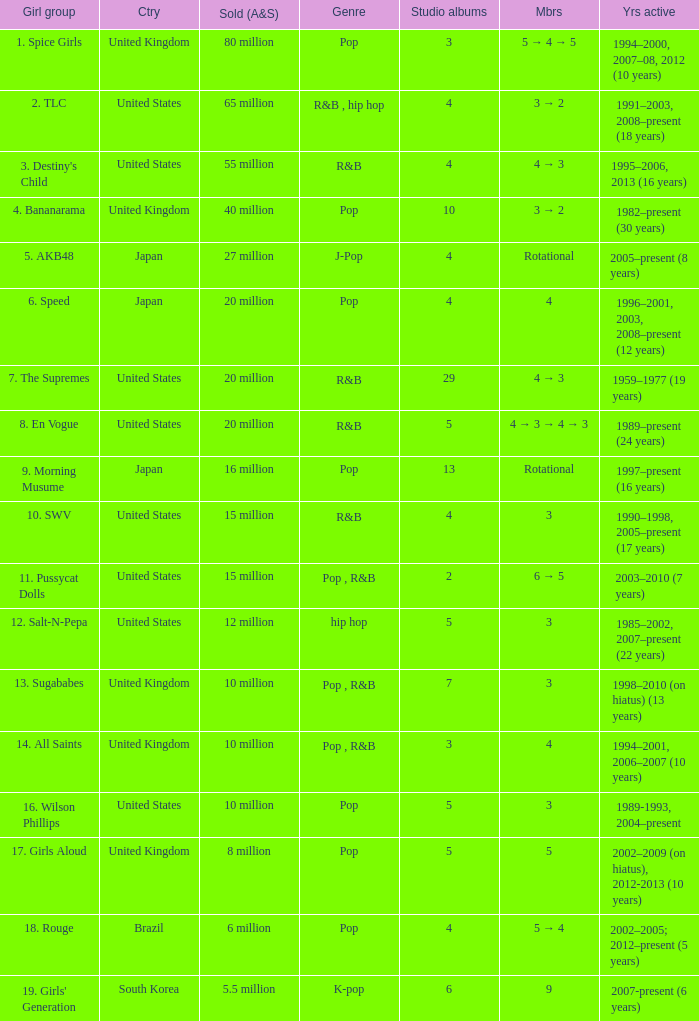How many members were in the group that sold 65 million albums and singles? 3 → 2. 